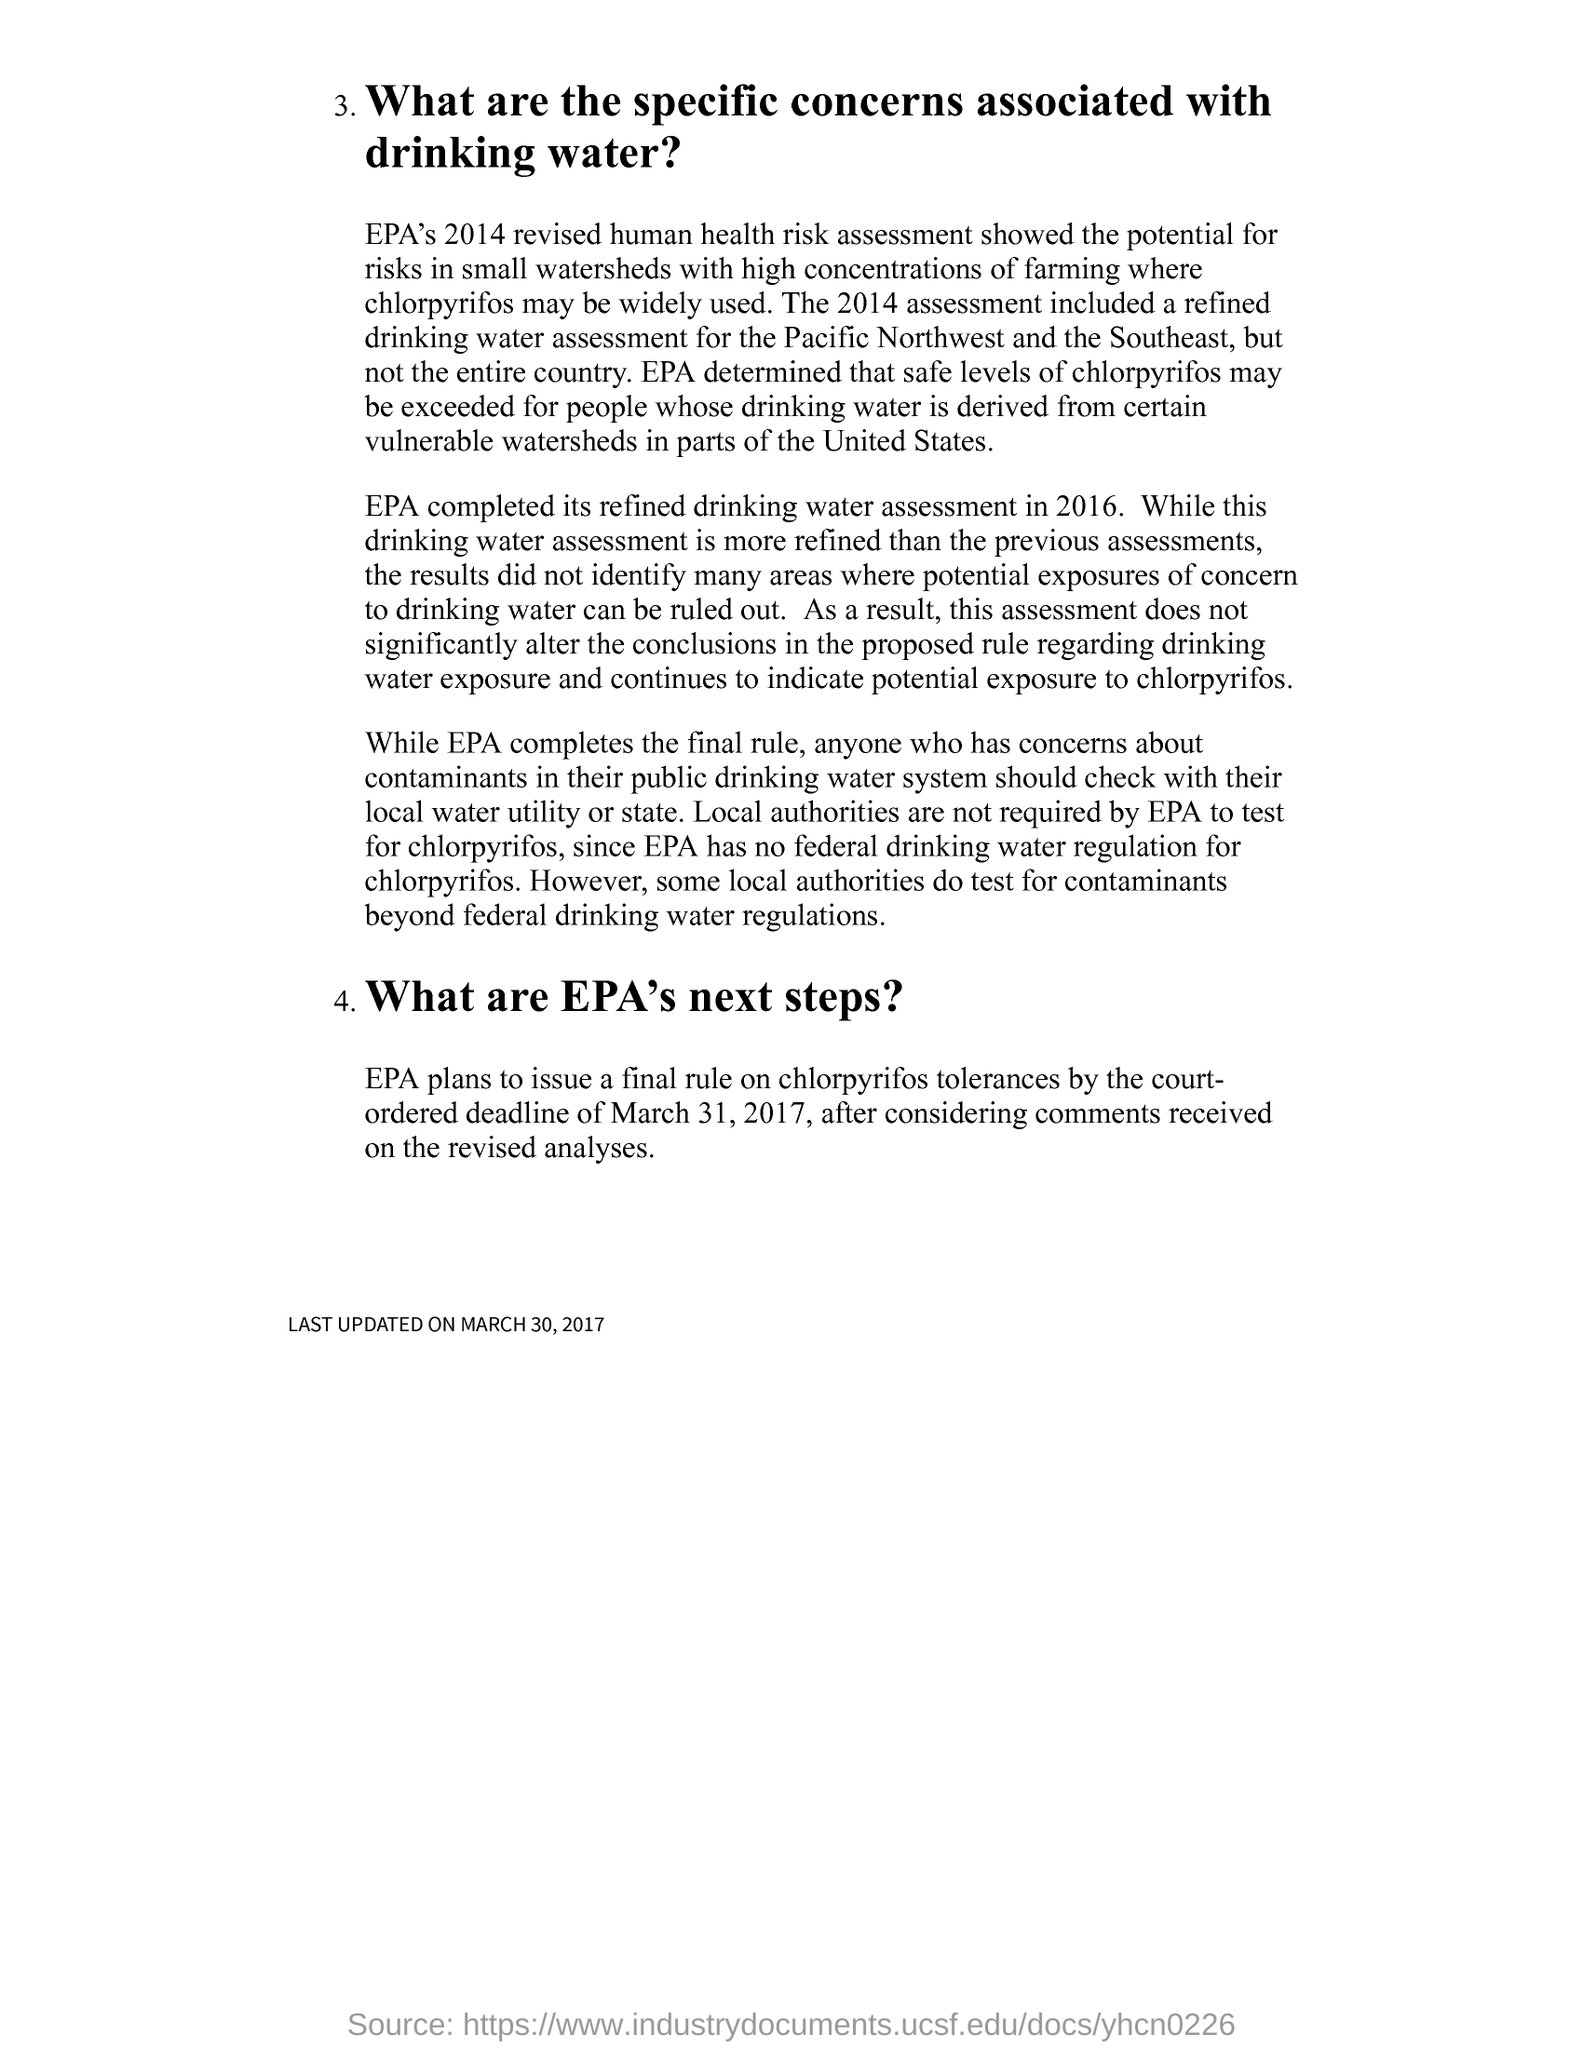Which was the court ordered deadline to issue a final rule on chlorpyrifos tolerances?
Offer a very short reply. MARCH 31, 2017. 